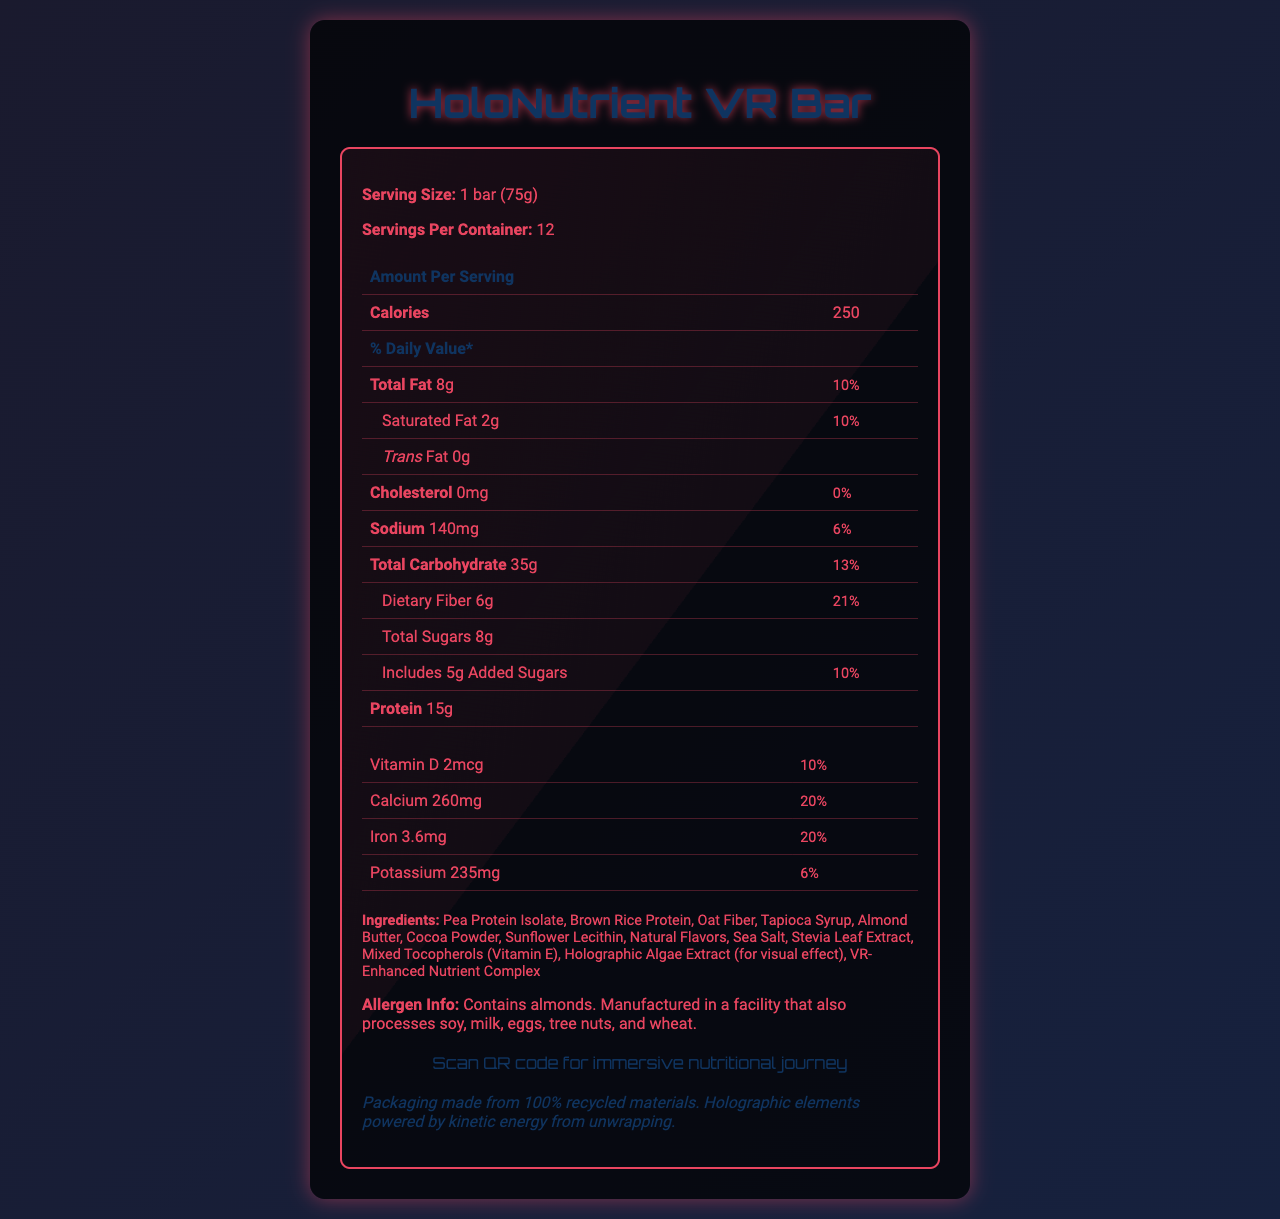what is the serving size of the HoloNutrient VR Bar? The serving size is clearly listed as "1 bar (75g)" at the top of the document.
Answer: 1 bar (75g) how many calories are in one serving of the HoloNutrient VR Bar? The calories per serving are listed as "250" in the "Amount Per Serving" section.
Answer: 250 what percentage of the daily value of dietary fiber is provided by one bar? The daily value percentage for dietary fiber is listed as "21%" in the table under dietary fiber.
Answer: 21% how much protein does one bar contain? The document states that one bar contains "15g" of protein in the "Amount Per Serving" section.
Answer: 15g what is the amount of added sugars in one bar? The amount of added sugars is listed as "5g" in the table under "Includes Added Sugars".
Answer: 5g which ingredient is listed last in the ingredients list? A. Pea Protein Isolate B. Almond Butter C. VR-Enhanced Nutrient Complex D. Sea Salt The last item in the ingredients list is "VR-Enhanced Nutrient Complex".
Answer: C. VR-Enhanced Nutrient Complex how many vitamins and minerals are listed in the nutrition facts section? Counting all the vitamins and minerals in the tables, there are 21 total listed.
Answer: 21 what is the primary fat source in the HoloNutrient VR Bar? The primary fat source mentioned in the ingredients is "Almond Butter".
Answer: Almond Butter does this product contain any cholesterol? The document states that it contains "0mg" of cholesterol and has a daily value of "0%", implying no cholesterol.
Answer: No describe the main visual and functional elements of the HoloNutrient VR Bar document. The document includes a detailed nutrition label with percentages of daily values, a list of ingredients, and additional information on allergens and sustainability. It also highlights the VR experience through a QR code and features holographic visual elements to enhance the contemporary design.
Answer: The document lists the nutritional facts, ingredients, allergen information, and sustainability note for the HoloNutrient VR Bar. The visual design is futuristic with holographic elements and a VR experience indicated by a QR code. what is the specific amount of Sodium per serving in the HoloNutrient VR Bar? The specific amount of sodium per serving is listed as "140mg" in the table.
Answer: 140mg which vitamins are at least 15% of the daily value per serving? A. Vitamin D B. Vitamin C C. Vitamin B12 D. Folate Both Vitamin B12 and Folate have a daily value percentage of 15% listed.
Answer: C. Vitamin B12 and D. Folate can we determine the manufacturing location from the document? The document mentions the product’s allergen information and facility processing, but does not specify the manufacturing location.
Answer: Not enough information what unique feature does the HoloNutrient VR Bar incorporate to enhance the consumer experience? The document mentions an immersive nutritional journey that consumers can access through scanning a QR code, indicating VR technology integration.
Answer: Immersive nutritional journey via VR experience 